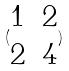Convert formula to latex. <formula><loc_0><loc_0><loc_500><loc_500>( \begin{matrix} 1 & 2 \\ 2 & 4 \end{matrix} )</formula> 